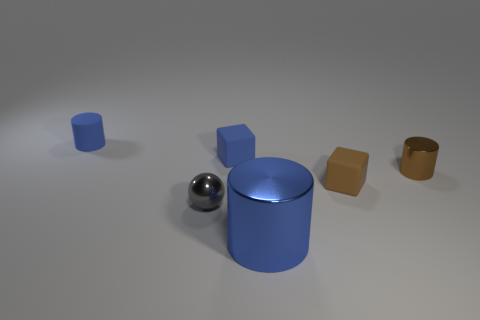Add 1 big purple spheres. How many objects exist? 7 Subtract all spheres. How many objects are left? 5 Add 1 small brown matte blocks. How many small brown matte blocks are left? 2 Add 1 small red matte blocks. How many small red matte blocks exist? 1 Subtract 1 brown cylinders. How many objects are left? 5 Subtract all large purple matte balls. Subtract all big metallic cylinders. How many objects are left? 5 